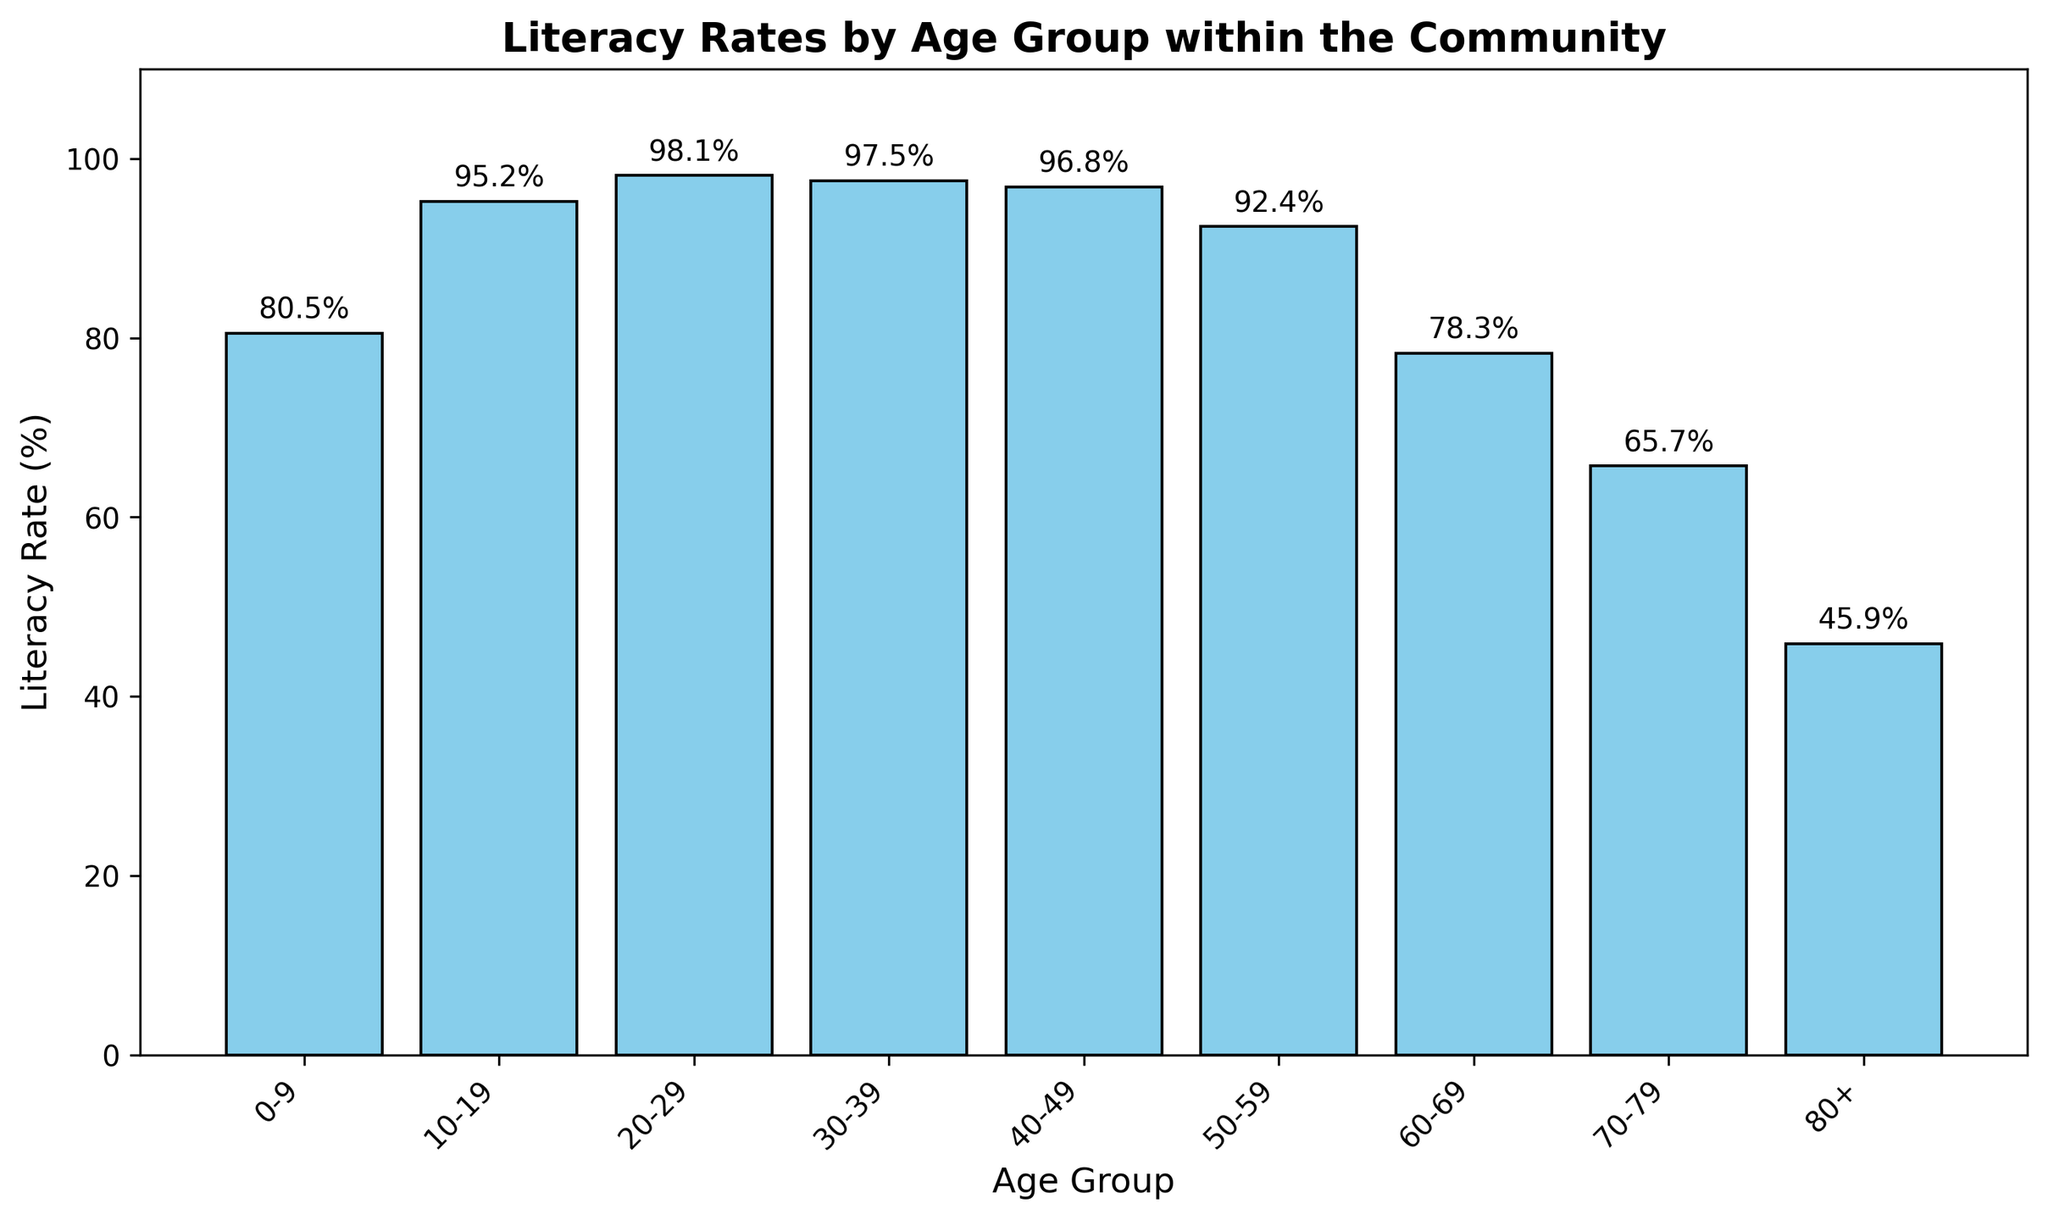What's the youngest age group with a literacy rate above 90%? Looking at the x-axis for age groups and checking the corresponding literacy rate on the y-axis, the youngest age group with a literacy rate above 90% is 10-19.
Answer: 10-19 What's the difference in literacy rates between the 20-29 and 60-69 age groups? Find the literacy rates for 20-29 (98.1%) and 60-69 (78.3%) from the bar heights, then subtract 78.3 from 98.1 to get the difference.
Answer: 19.8% Which age group has the lowest literacy rate? Identify the shortest bar on the plot, which corresponds to the age group 80+.
Answer: 80+ Is the literacy rate for the age group 30-39 higher than for the age group 50-59? Compare the heights of the bars for 30-39 (97.5%) and 50-59 (92.4%). The 30-39 bar is higher.
Answer: Yes What is the average literacy rate for the age groups from 50-59 to 80+? Sum the literacy rates for 50-59 (92.4%), 60-69 (78.3%), 70-79 (65.7%), and 80+ (45.9%), then divide by the number of groups (4). (92.4 + 78.3 + 65.7 + 45.9) / 4 = 70.575.
Answer: 70.6% How much lower is the literacy rate of the age group 70-79 compared to 0-9? Find the literacy rates for 70-79 (65.7%) and 0-9 (80.5%), then subtract 65.7 from 80.5.
Answer: 14.8% Which age group shows the highest literacy rate? Identify the tallest bar on the chart, which corresponds to the 20-29 age group.
Answer: 20-29 What is the decline in literacy rate from the 40-49 age group to the 80+ age group? Find the literacy rates for 40-49 (96.8%) and 80+ (45.9%), then subtract 45.9 from 96.8.
Answer: 50.9% What's the total literacy rate if you sum the rates of the 0-9 and 10-19 age groups? Add the literacy rates of 0-9 (80.5%) and 10-19 (95.2%) together.
Answer: 175.7% How does the literacy rate of 20-29 compare to that of 30-39? Both literacy rate bars for 20-29 (98.1%) and 30-39 (97.5%) are close in height, but 20-29 is slightly higher.
Answer: 20-29 is higher 